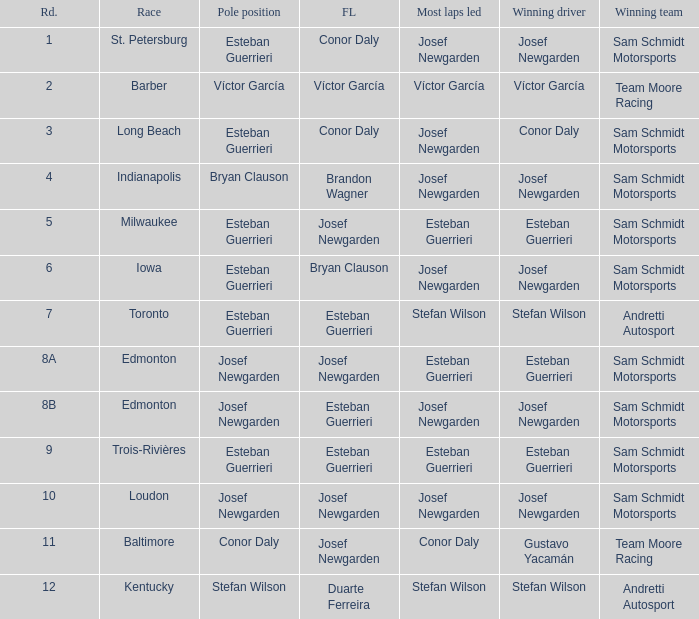Who had the fastest lap(s) when stefan wilson had the pole? Duarte Ferreira. 